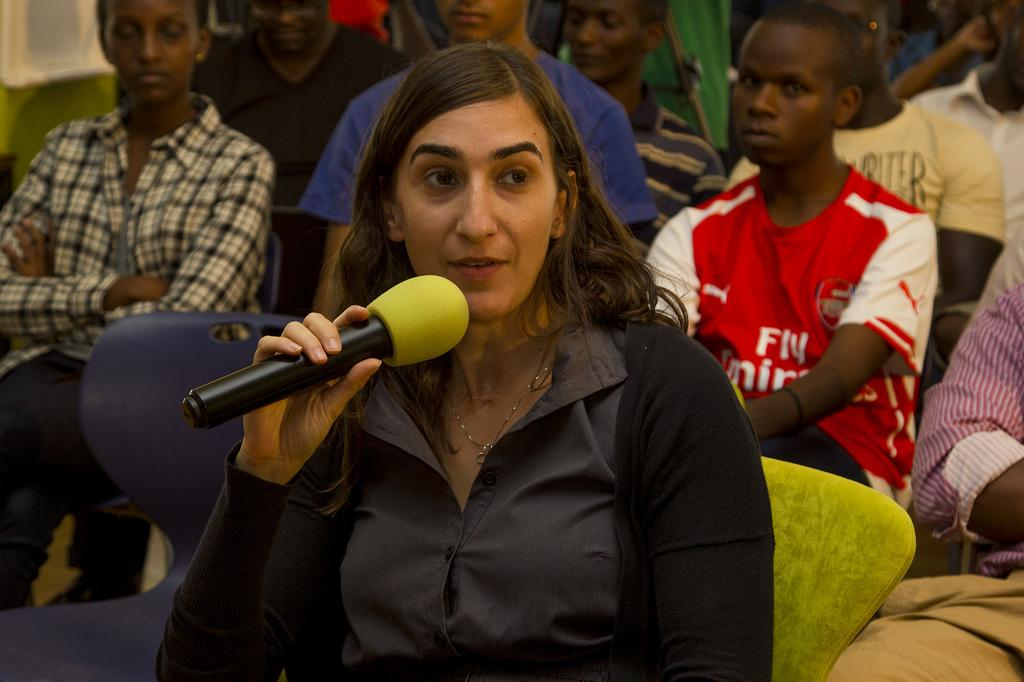Who is the main subject in the image? There is a woman in the image. What is the woman doing in the image? The woman is speaking into a microphone. Can you describe the people in the image? There are people sitting on chairs in the image. What type of sail can be seen on the woman's shirt in the image? There is no sail visible on the woman's shirt in the image. Is there a party happening in the image? The image does not provide any information about a party taking place. 